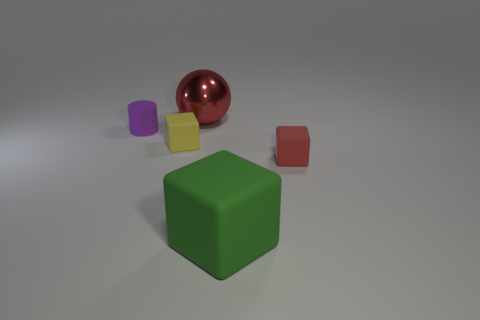There is a thing behind the small rubber thing that is left of the yellow object; is there a large shiny object that is to the right of it?
Keep it short and to the point. No. Are there more big things that are behind the purple rubber object than tiny rubber blocks that are to the left of the green rubber object?
Offer a very short reply. No. What is the material of the block that is the same size as the red sphere?
Ensure brevity in your answer.  Rubber. How many large things are red rubber objects or metallic balls?
Keep it short and to the point. 1. Is the shape of the red shiny object the same as the green object?
Your answer should be very brief. No. What number of things are both to the right of the purple cylinder and behind the large green cube?
Ensure brevity in your answer.  3. Are there any other things that have the same color as the metallic ball?
Your answer should be compact. Yes. The green thing that is made of the same material as the small purple object is what shape?
Provide a short and direct response. Cube. Is the red matte block the same size as the yellow matte block?
Offer a terse response. Yes. Does the small cube that is on the right side of the metallic ball have the same material as the small yellow block?
Your answer should be compact. Yes. 